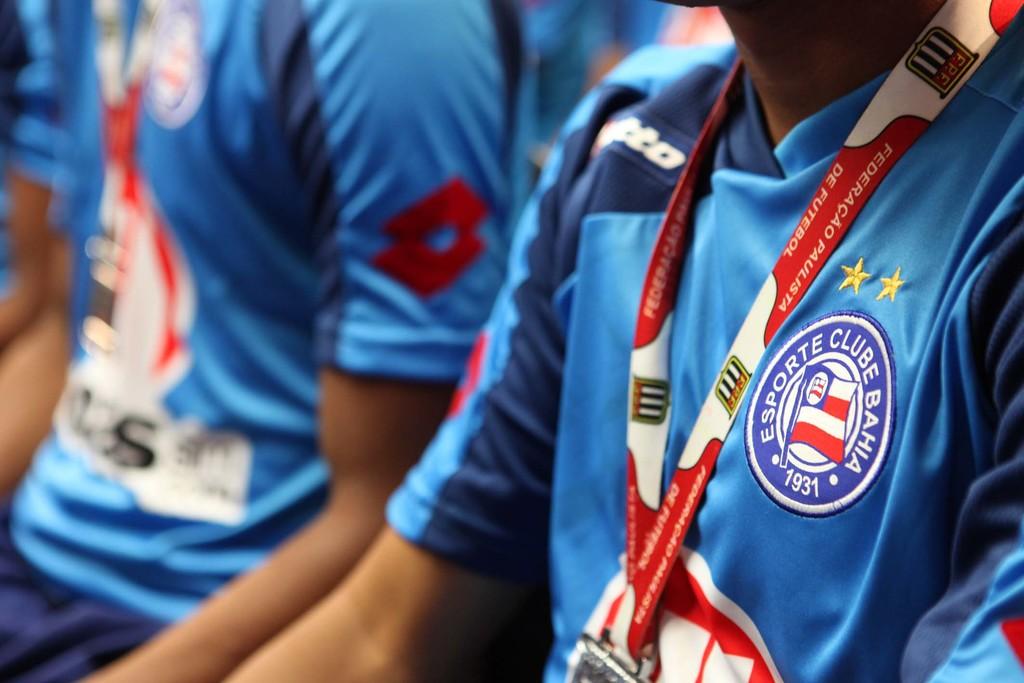What team is that?
Offer a very short reply. Esporte clube bahia. 